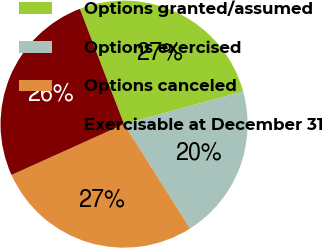<chart> <loc_0><loc_0><loc_500><loc_500><pie_chart><fcel>Options granted/assumed<fcel>Options exercised<fcel>Options canceled<fcel>Exercisable at December 31<nl><fcel>26.57%<fcel>20.28%<fcel>27.22%<fcel>25.92%<nl></chart> 